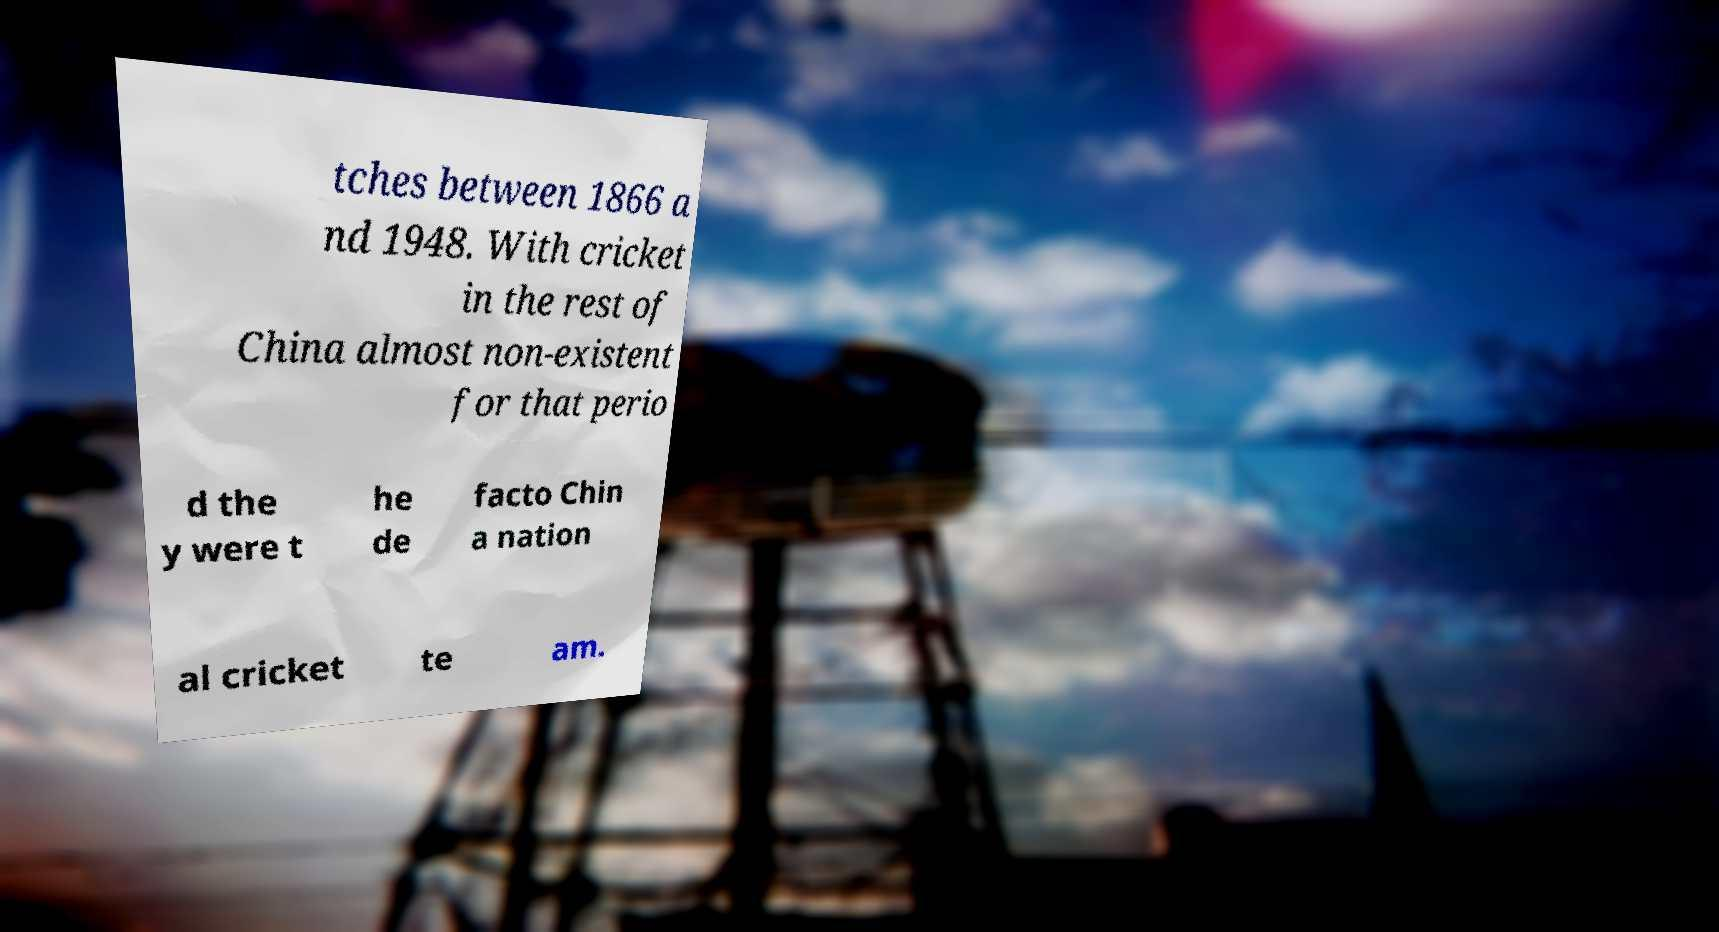What messages or text are displayed in this image? I need them in a readable, typed format. tches between 1866 a nd 1948. With cricket in the rest of China almost non-existent for that perio d the y were t he de facto Chin a nation al cricket te am. 